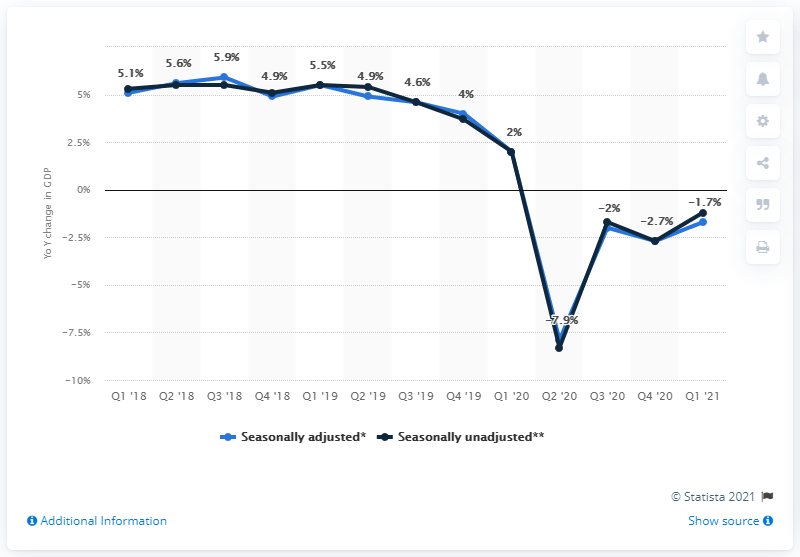Specify some key components in this picture. The difference between Q1 2018 and Q1 2021 is 6.8%. The light blue line represents the seasonally adjusted data, which takes into account regular fluctuations in a given series and removes them to better reflect the underlying trend. 